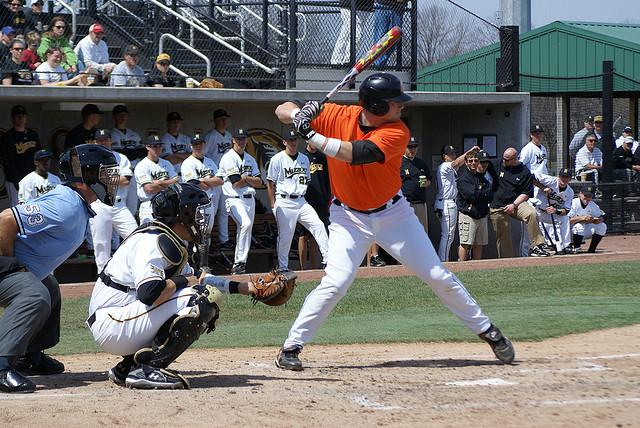What is the brown object in the squatting man's hand? Please explain your reasoning. glove. The catcher is using a mitt on his left hand. 